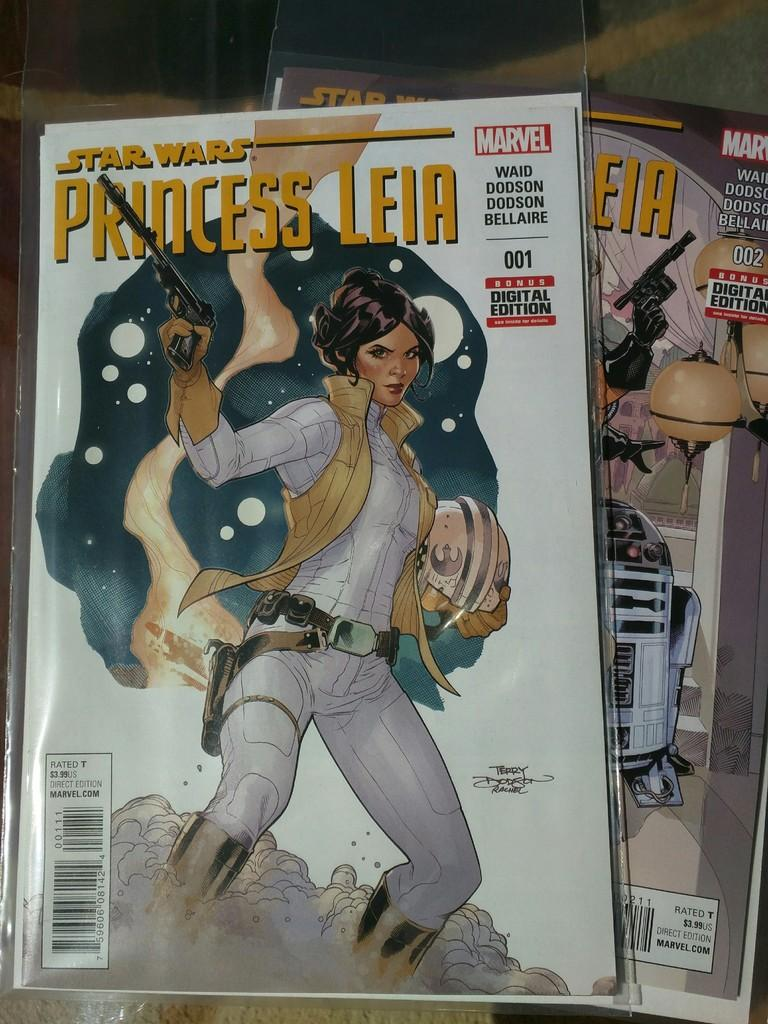What objects are in the center of the image? There are two books in the center of the image. What is the woman doing in the image? The woman is standing on the books. What is the woman holding in the image? The woman is holding a gun. Can you describe any text visible in the image? There is text written on the books or nearby. How many cattle can be seen grazing in the background of the image? There are no cattle visible in the image; it features two books, a woman standing on them, and a gun. What type of dust is present on the books in the image? There is no dust visible on the books in the image. 